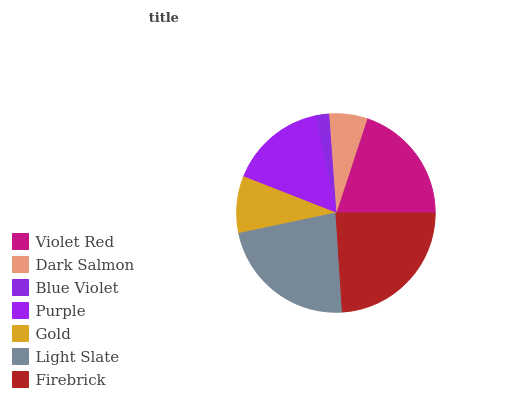Is Blue Violet the minimum?
Answer yes or no. Yes. Is Firebrick the maximum?
Answer yes or no. Yes. Is Dark Salmon the minimum?
Answer yes or no. No. Is Dark Salmon the maximum?
Answer yes or no. No. Is Violet Red greater than Dark Salmon?
Answer yes or no. Yes. Is Dark Salmon less than Violet Red?
Answer yes or no. Yes. Is Dark Salmon greater than Violet Red?
Answer yes or no. No. Is Violet Red less than Dark Salmon?
Answer yes or no. No. Is Purple the high median?
Answer yes or no. Yes. Is Purple the low median?
Answer yes or no. Yes. Is Dark Salmon the high median?
Answer yes or no. No. Is Gold the low median?
Answer yes or no. No. 